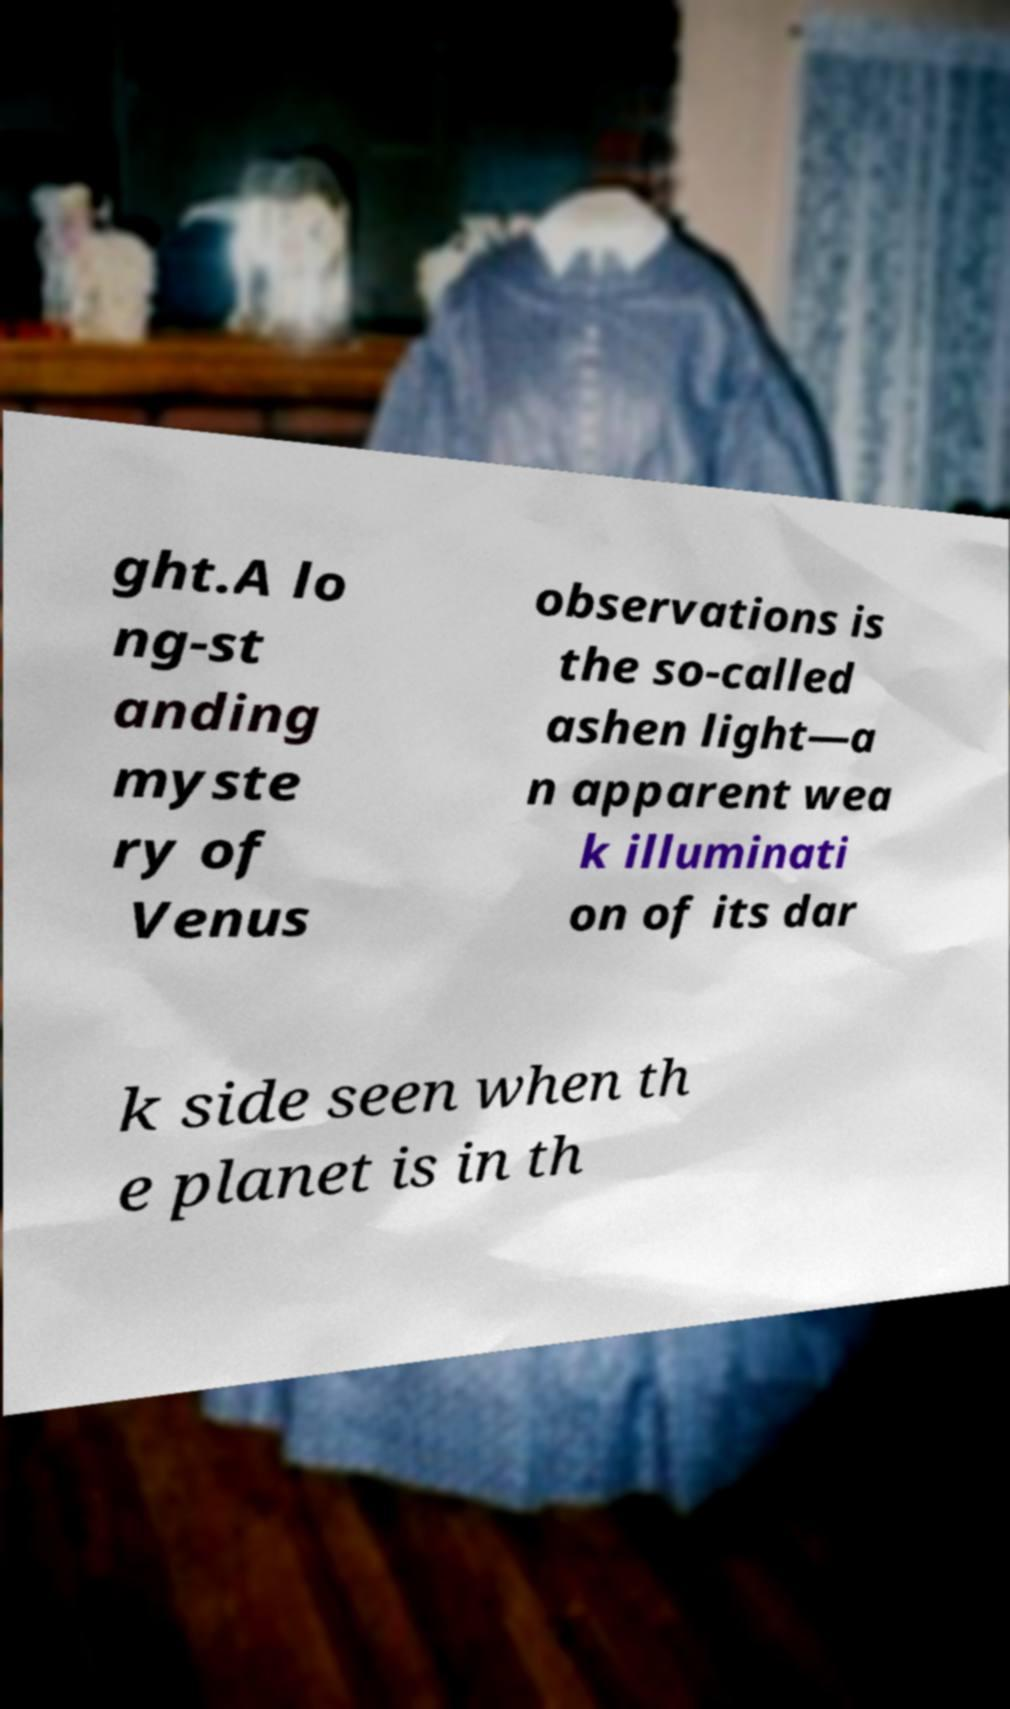Can you accurately transcribe the text from the provided image for me? ght.A lo ng-st anding myste ry of Venus observations is the so-called ashen light—a n apparent wea k illuminati on of its dar k side seen when th e planet is in th 